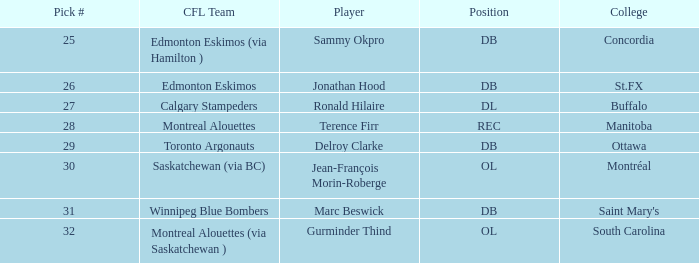Which college has an ol position and a selection number less than 32? Montréal. 